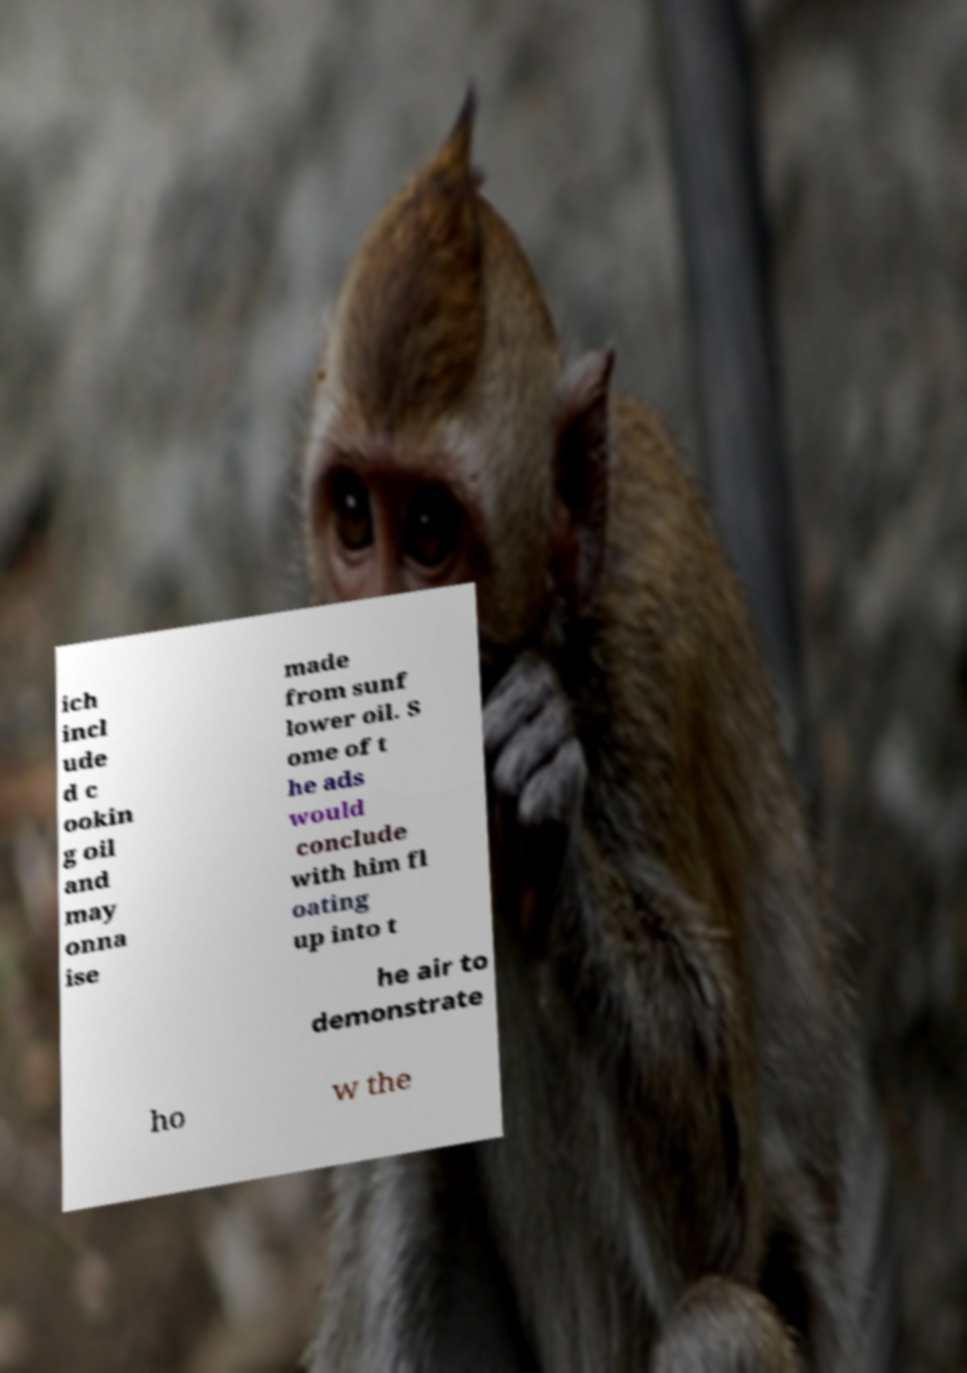What messages or text are displayed in this image? I need them in a readable, typed format. ich incl ude d c ookin g oil and may onna ise made from sunf lower oil. S ome of t he ads would conclude with him fl oating up into t he air to demonstrate ho w the 